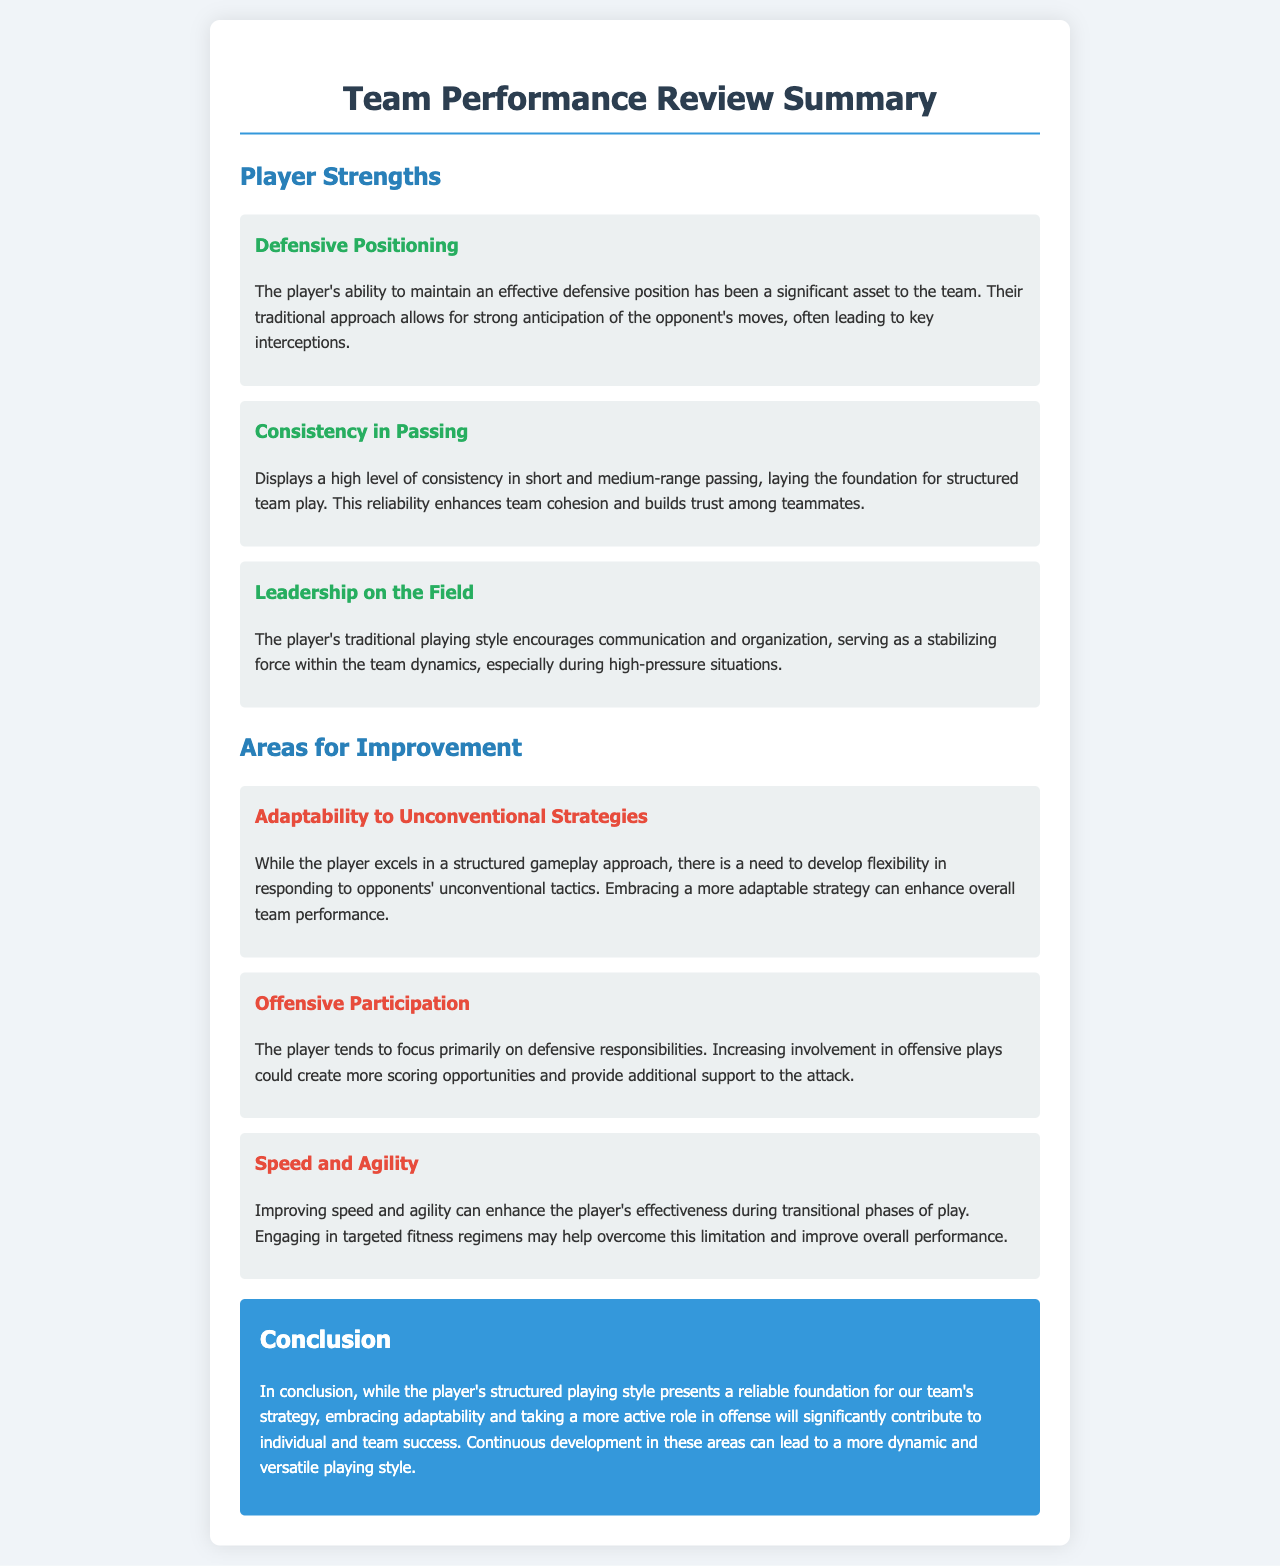What is the player's strength in defensive skills? The document states that the player's ability to maintain an effective defensive position is a significant asset.
Answer: Defensive Positioning How many player strengths are highlighted in the summary? The document lists three distinct player strengths under "Player Strengths."
Answer: Three What leadership quality does the player exhibit? The document highlights that the player's traditional playing style encourages communication and organization.
Answer: Leadership on the Field What is one area for improvement related to the player's strategy? The document suggests that the player needs to develop flexibility in responding to opponents' unconventional tactics.
Answer: Adaptability to Unconventional Strategies Which aspect of the player's physical attributes needs improvement? The document mentions that improving speed and agility can enhance the player's effectiveness.
Answer: Speed and Agility What is suggested to increase the player's offensive involvement? The document discusses the need for the player to increase involvement in offensive plays.
Answer: Offensive Participation What is the conclusion regarding the player's playing style? The conclusion states that embracing adaptability and taking a more active role in offense will contribute to success.
Answer: Embracing adaptability Which color is used for headings in the strengths section? The document uses a specific color for headings of strengths.
Answer: Green What is the background color of the conclusion section? The document specifies a distinct background color for the conclusion section.
Answer: Blue 